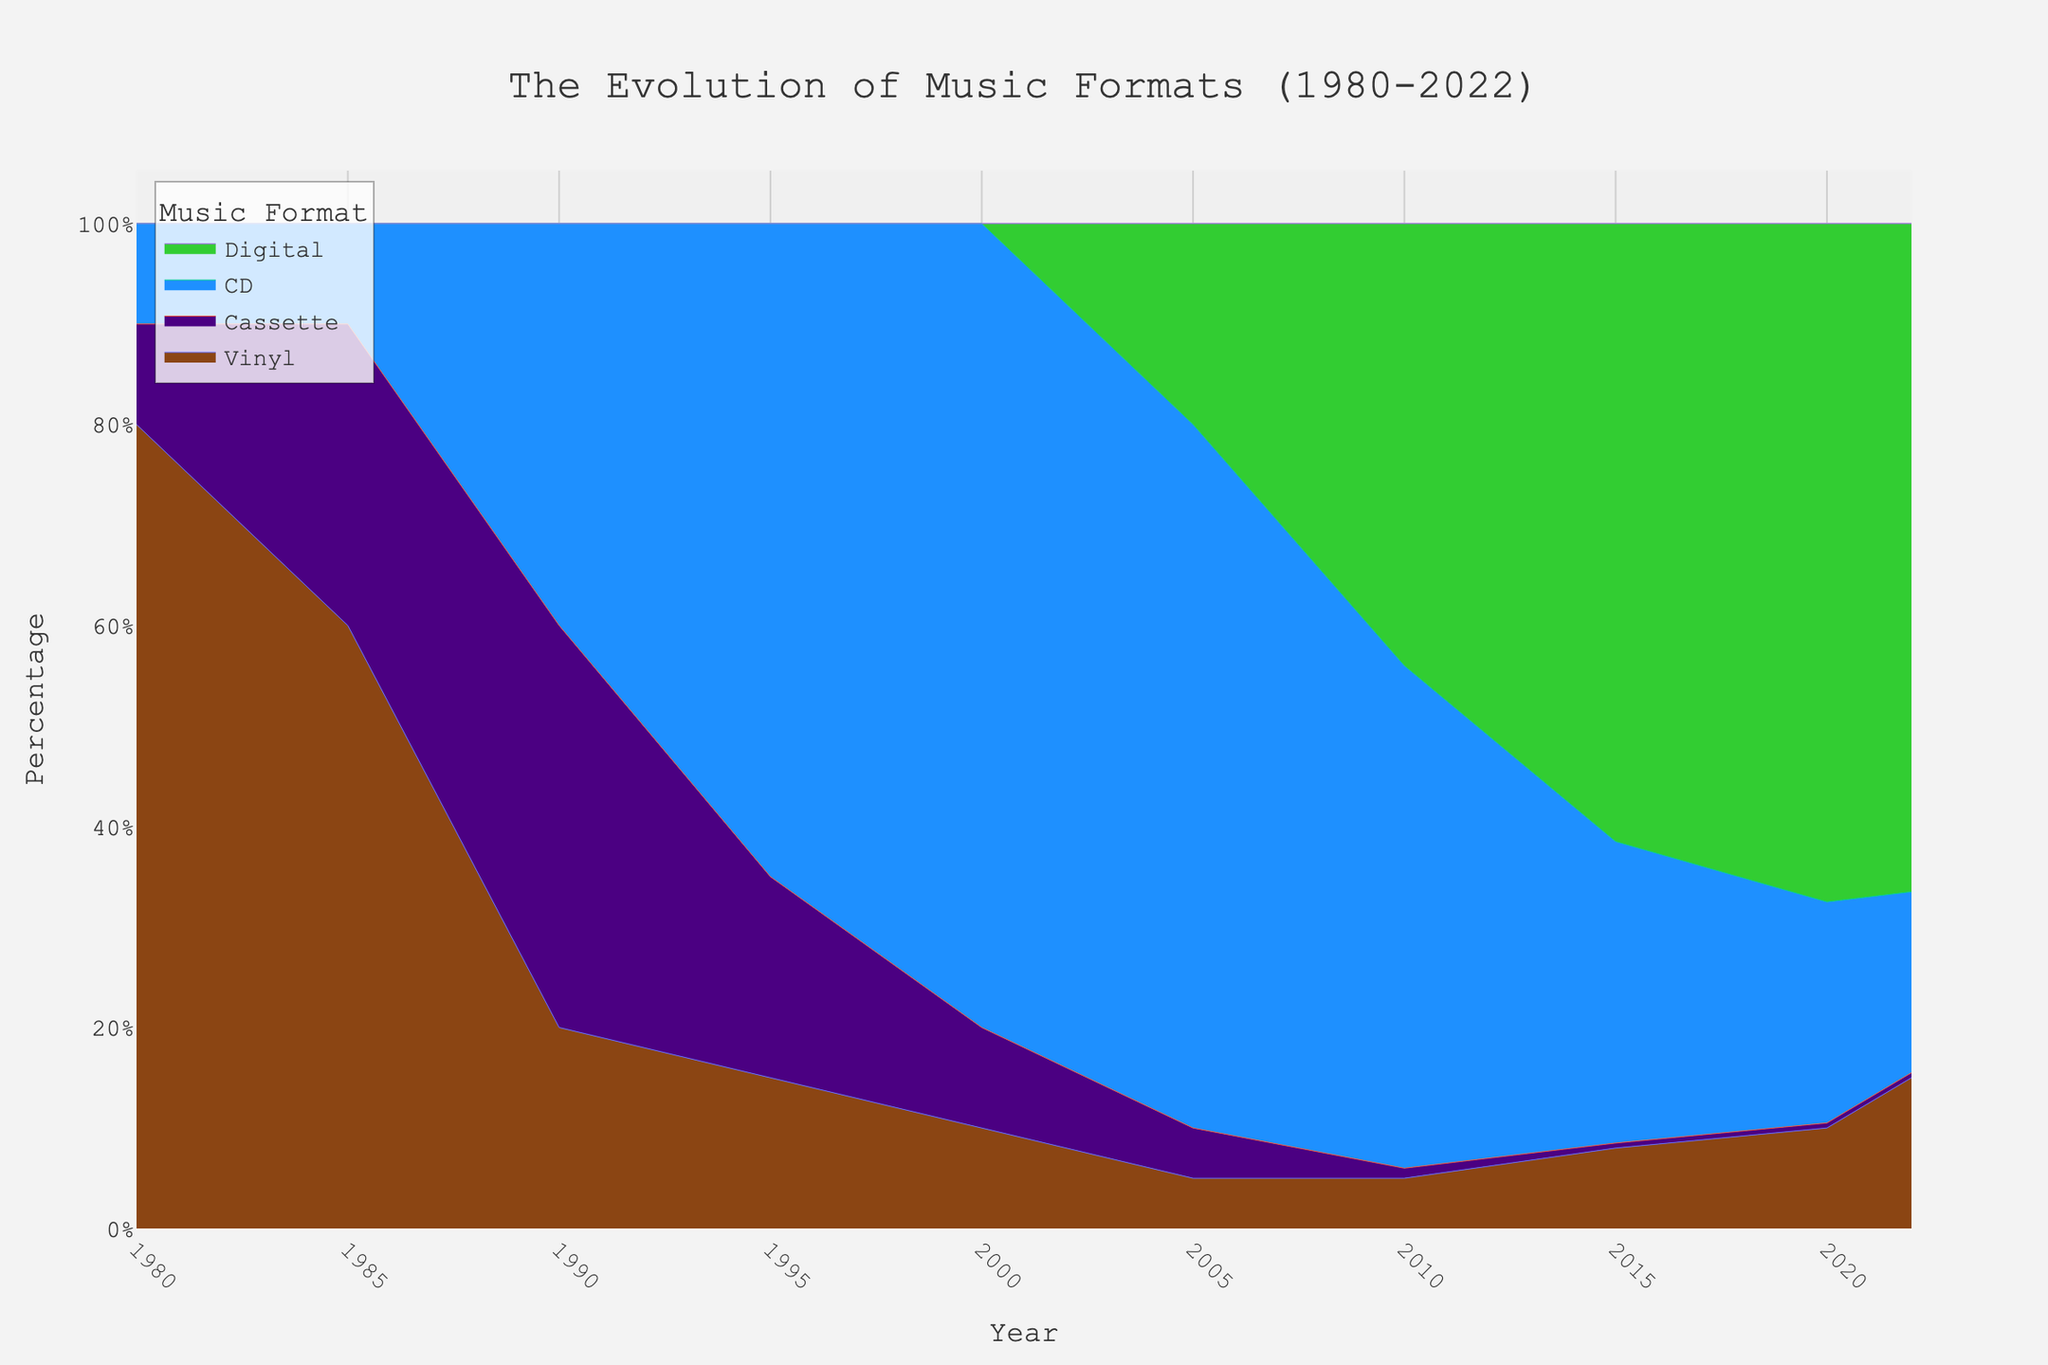How does the popularity of vinyl records change from 1980 to 2000? In 1980, vinyl holds 80% of the market. By 2000, its share drops to 10%.
Answer: It decreases from 80% to 10% What fraction of the music market did digital formats capture in 2010? In 2010, the digital format accounts for 44% of the market.
Answer: 44% What years did CDs hold more than 50% of the market? CDs surpass 50% from 1995 to 2010.
Answer: 1995 to 2010 Which format experienced the most significant decline in popularity between 1990 and 2020? Cassette tapes drop from 40% to 0.5% during this period.
Answer: Cassettes Is digital the dominant music format by 2022? By 2022, digital formats hold 66.5%, which is the highest.
Answer: Yes Calculate the percentage change in the CD market share from 2000 to 2015. From 2000 (80%) to 2015 (30%), CD market share decreased by (80% - 30%) = 50%. To find the percentage change: (50/80) * 100% = 62.5%.
Answer: 62.5% Compare vinyl’s and cassette tapes' market shares in 1985. Which was more popular? Vinyl had 60%, and cassettes had 30% in 1985. Vinyl was more popular.
Answer: Vinyl By what factor did the market share of digital formats increase from 2005 to 2020? Digital formats increased from 20% in 2005 to 67.5% in 2020. The factor increase is 67.5 / 20 = 3.375.
Answer: 3.375 How did the market share of vinyl change between 2015 and 2022? Vinyl's share increased from 8% in 2015 to 15% in 2022. It doubled.
Answer: It doubled What was the lowest point for the market share of cassette tapes, and in which year did this occur? The lowest point for cassettes is 0.5%, occurring from 2015 to 2022.
Answer: 2015 to 2022 